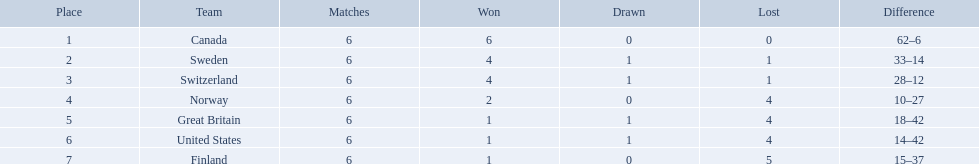Which are the two countries? Switzerland, Great Britain. What were the point totals for each of these countries? 9, 3. Of these point totals, which is better? 9. Which country earned this point total? Switzerland. 